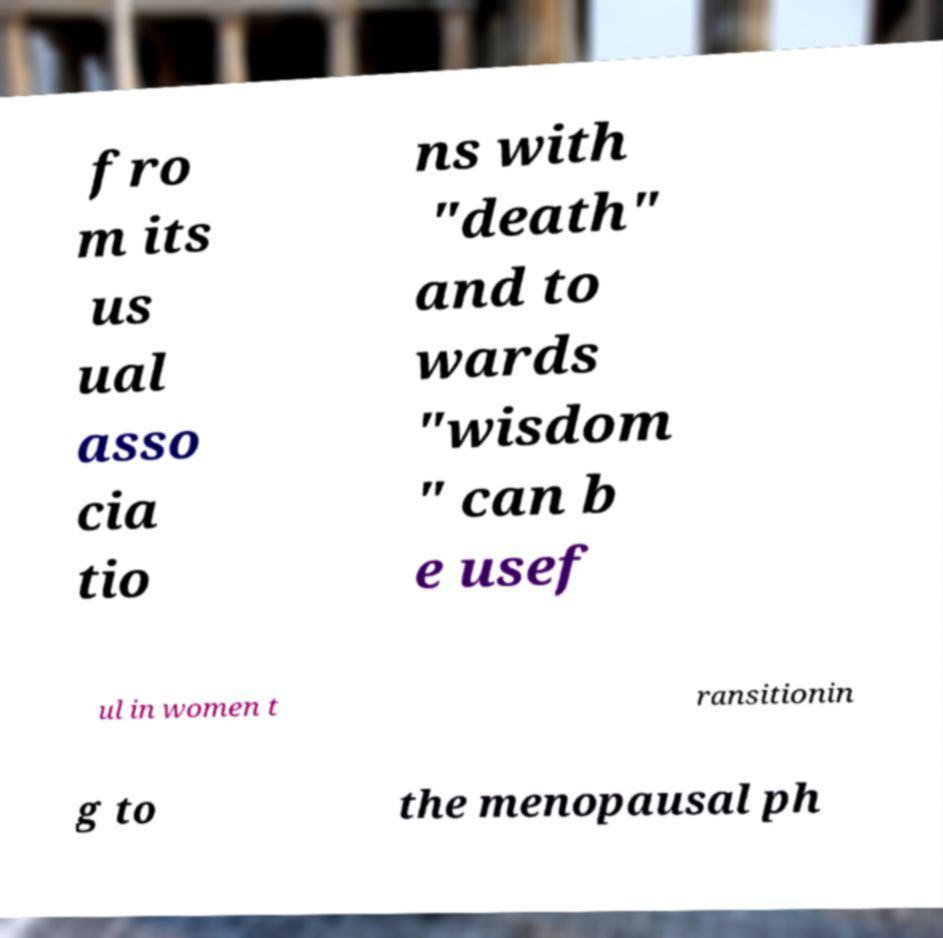Could you extract and type out the text from this image? fro m its us ual asso cia tio ns with "death" and to wards "wisdom " can b e usef ul in women t ransitionin g to the menopausal ph 